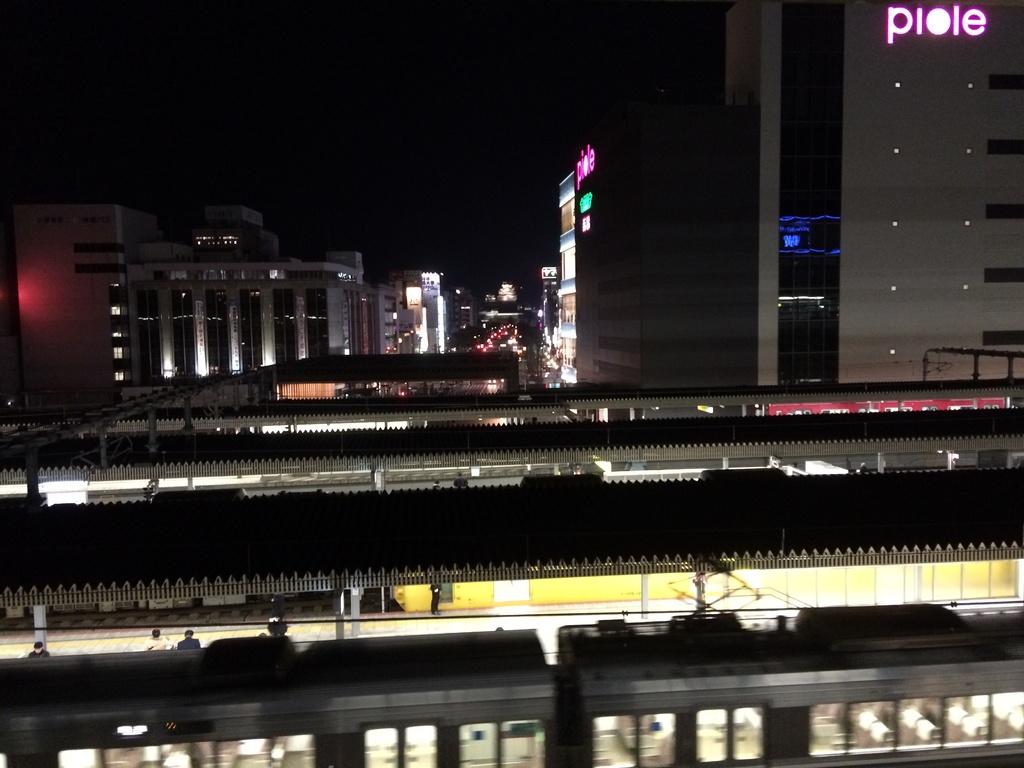What does the sign say on the building on the right?
Offer a terse response. Piole. What is the name on the tallest building?
Make the answer very short. Piole. 